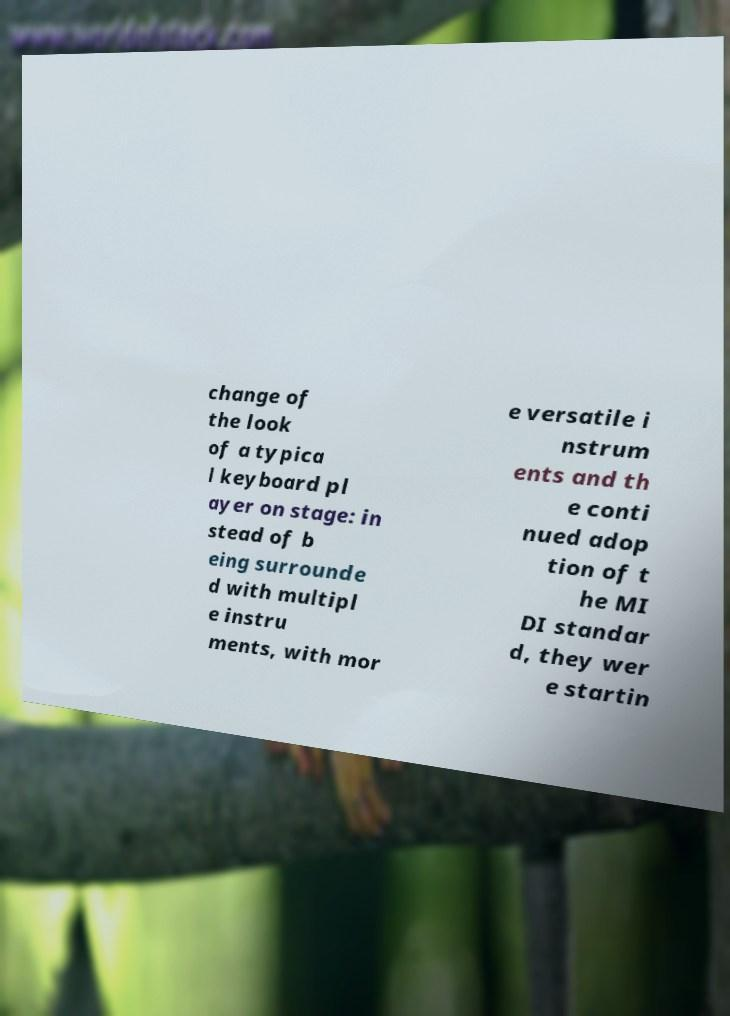Please identify and transcribe the text found in this image. change of the look of a typica l keyboard pl ayer on stage: in stead of b eing surrounde d with multipl e instru ments, with mor e versatile i nstrum ents and th e conti nued adop tion of t he MI DI standar d, they wer e startin 